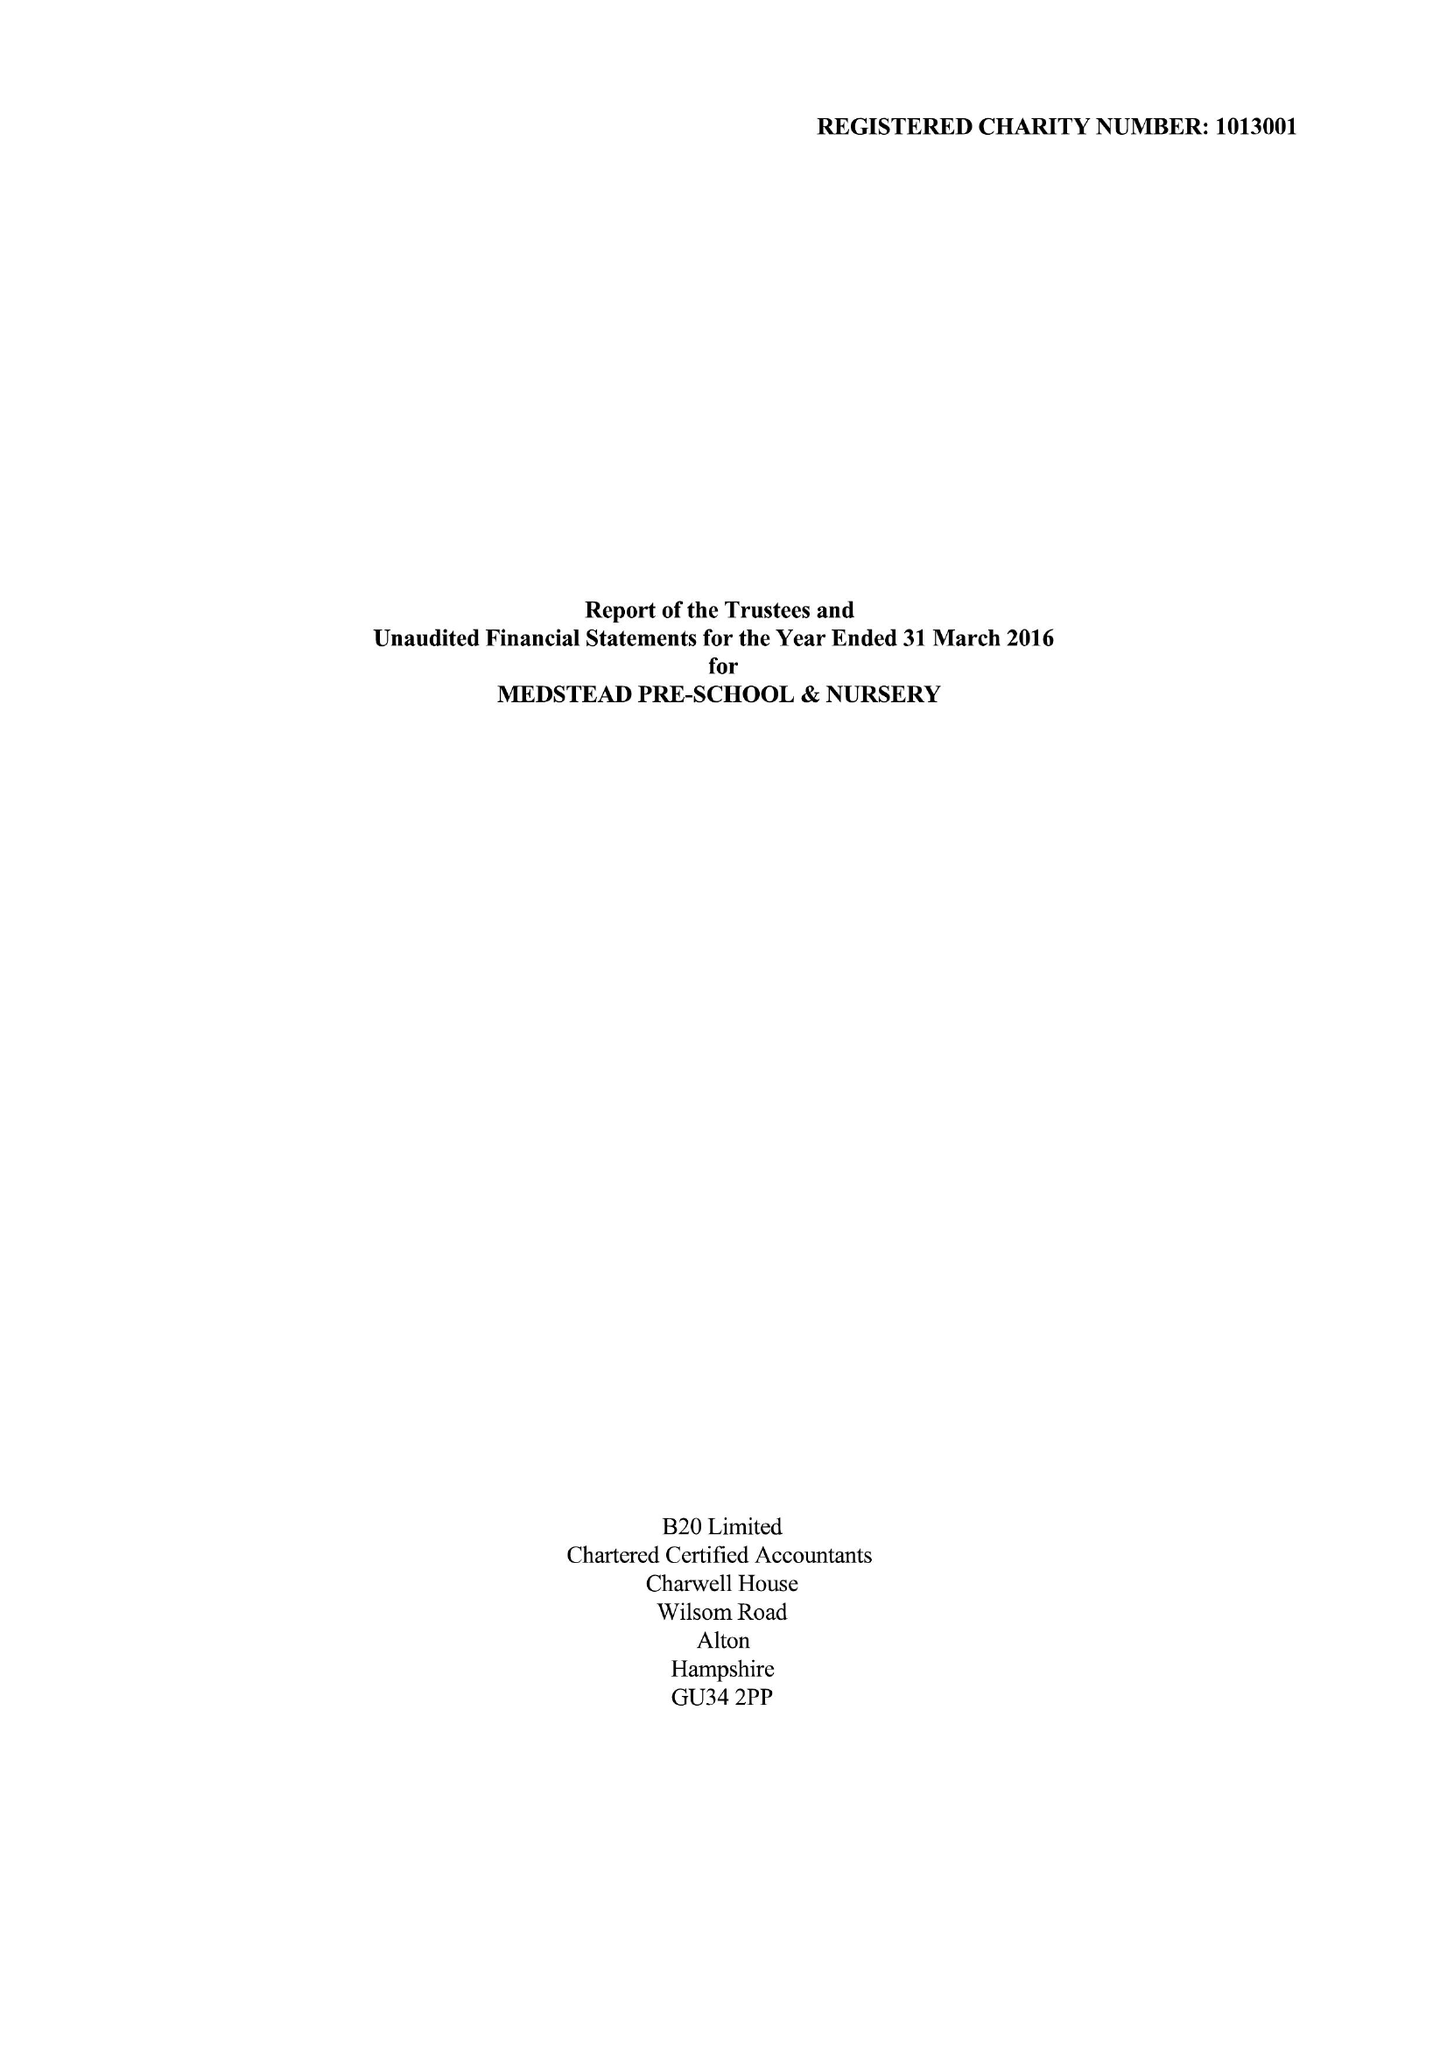What is the value for the charity_name?
Answer the question using a single word or phrase. Medstead Pre-School and Nursery 